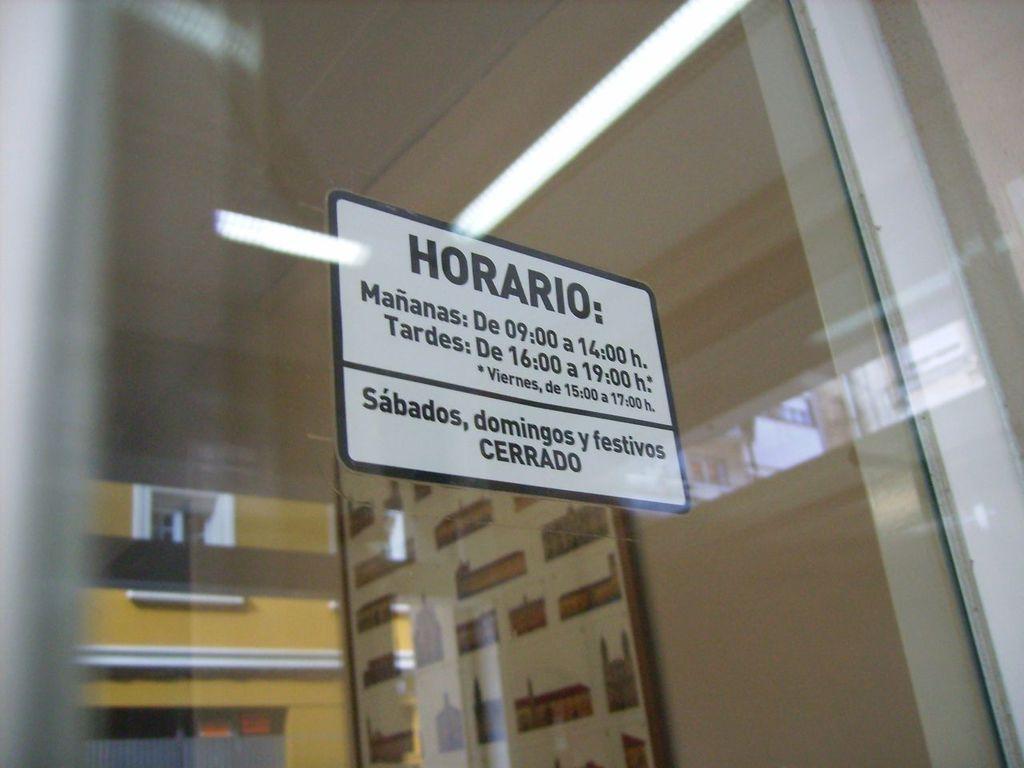How would you summarize this image in a sentence or two? In this image we can see a board on the glass and through the glass we can see frame on the wall and on the glass we can see the reflections of a building, window and lights. 